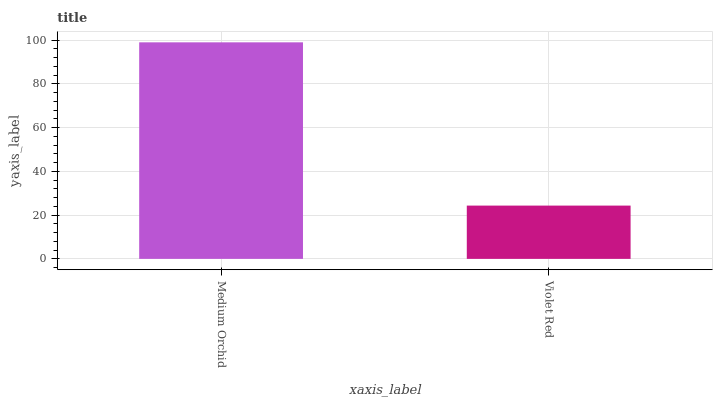Is Violet Red the minimum?
Answer yes or no. Yes. Is Medium Orchid the maximum?
Answer yes or no. Yes. Is Violet Red the maximum?
Answer yes or no. No. Is Medium Orchid greater than Violet Red?
Answer yes or no. Yes. Is Violet Red less than Medium Orchid?
Answer yes or no. Yes. Is Violet Red greater than Medium Orchid?
Answer yes or no. No. Is Medium Orchid less than Violet Red?
Answer yes or no. No. Is Medium Orchid the high median?
Answer yes or no. Yes. Is Violet Red the low median?
Answer yes or no. Yes. Is Violet Red the high median?
Answer yes or no. No. Is Medium Orchid the low median?
Answer yes or no. No. 